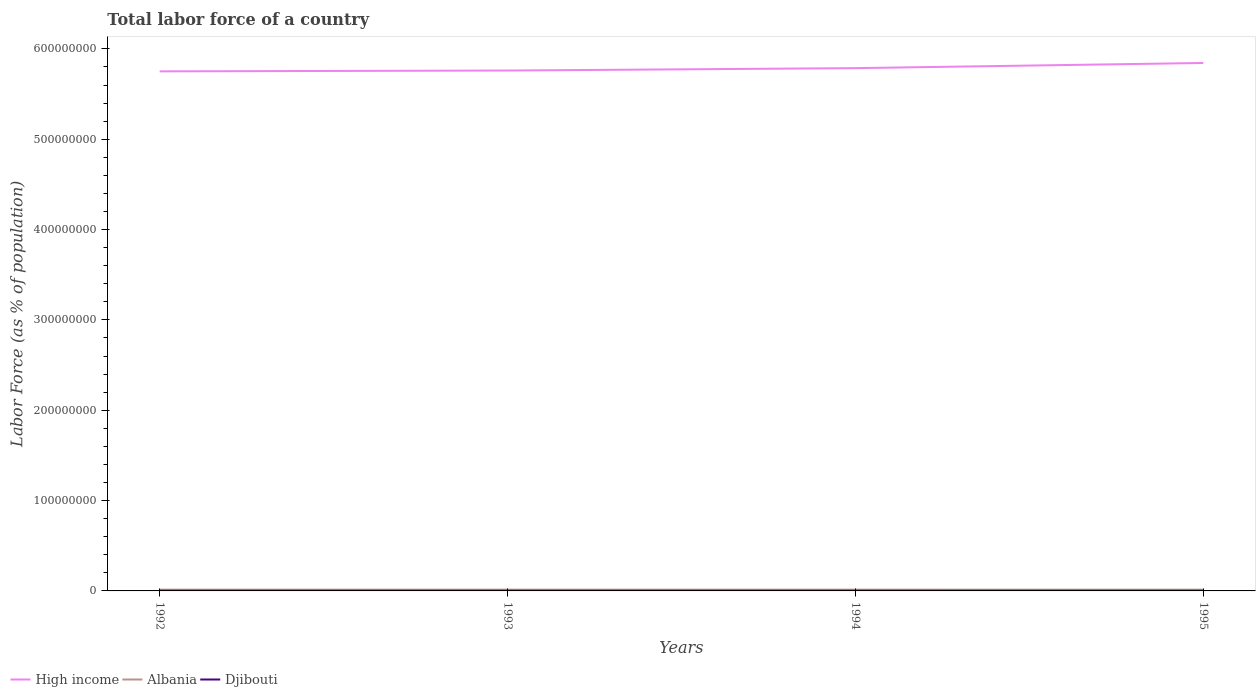How many different coloured lines are there?
Your answer should be very brief. 3. Does the line corresponding to Albania intersect with the line corresponding to High income?
Your answer should be compact. No. Is the number of lines equal to the number of legend labels?
Offer a very short reply. Yes. Across all years, what is the maximum percentage of labor force in Albania?
Give a very brief answer. 1.38e+06. In which year was the percentage of labor force in High income maximum?
Offer a very short reply. 1992. What is the total percentage of labor force in Djibouti in the graph?
Offer a very short reply. -5135. What is the difference between the highest and the second highest percentage of labor force in Djibouti?
Provide a short and direct response. 1.55e+04. How many lines are there?
Make the answer very short. 3. How many years are there in the graph?
Offer a very short reply. 4. What is the difference between two consecutive major ticks on the Y-axis?
Your answer should be compact. 1.00e+08. Are the values on the major ticks of Y-axis written in scientific E-notation?
Offer a terse response. No. How many legend labels are there?
Your answer should be compact. 3. How are the legend labels stacked?
Give a very brief answer. Horizontal. What is the title of the graph?
Keep it short and to the point. Total labor force of a country. Does "Saudi Arabia" appear as one of the legend labels in the graph?
Ensure brevity in your answer.  No. What is the label or title of the Y-axis?
Give a very brief answer. Labor Force (as % of population). What is the Labor Force (as % of population) in High income in 1992?
Give a very brief answer. 5.75e+08. What is the Labor Force (as % of population) of Albania in 1992?
Offer a terse response. 1.42e+06. What is the Labor Force (as % of population) in Djibouti in 1992?
Make the answer very short. 1.63e+05. What is the Labor Force (as % of population) in High income in 1993?
Keep it short and to the point. 5.76e+08. What is the Labor Force (as % of population) in Albania in 1993?
Your answer should be very brief. 1.41e+06. What is the Labor Force (as % of population) of Djibouti in 1993?
Make the answer very short. 1.69e+05. What is the Labor Force (as % of population) of High income in 1994?
Make the answer very short. 5.79e+08. What is the Labor Force (as % of population) of Albania in 1994?
Keep it short and to the point. 1.39e+06. What is the Labor Force (as % of population) of Djibouti in 1994?
Make the answer very short. 1.74e+05. What is the Labor Force (as % of population) of High income in 1995?
Your answer should be compact. 5.84e+08. What is the Labor Force (as % of population) in Albania in 1995?
Offer a very short reply. 1.38e+06. What is the Labor Force (as % of population) of Djibouti in 1995?
Offer a terse response. 1.79e+05. Across all years, what is the maximum Labor Force (as % of population) of High income?
Make the answer very short. 5.84e+08. Across all years, what is the maximum Labor Force (as % of population) in Albania?
Offer a very short reply. 1.42e+06. Across all years, what is the maximum Labor Force (as % of population) of Djibouti?
Provide a short and direct response. 1.79e+05. Across all years, what is the minimum Labor Force (as % of population) in High income?
Provide a succinct answer. 5.75e+08. Across all years, what is the minimum Labor Force (as % of population) of Albania?
Your answer should be very brief. 1.38e+06. Across all years, what is the minimum Labor Force (as % of population) in Djibouti?
Give a very brief answer. 1.63e+05. What is the total Labor Force (as % of population) of High income in the graph?
Provide a short and direct response. 2.31e+09. What is the total Labor Force (as % of population) in Albania in the graph?
Give a very brief answer. 5.59e+06. What is the total Labor Force (as % of population) of Djibouti in the graph?
Make the answer very short. 6.85e+05. What is the difference between the Labor Force (as % of population) of High income in 1992 and that in 1993?
Your response must be concise. -9.15e+05. What is the difference between the Labor Force (as % of population) in Albania in 1992 and that in 1993?
Make the answer very short. 1.21e+04. What is the difference between the Labor Force (as % of population) in Djibouti in 1992 and that in 1993?
Keep it short and to the point. -5453. What is the difference between the Labor Force (as % of population) of High income in 1992 and that in 1994?
Your response must be concise. -3.57e+06. What is the difference between the Labor Force (as % of population) of Albania in 1992 and that in 1994?
Your response must be concise. 2.33e+04. What is the difference between the Labor Force (as % of population) in Djibouti in 1992 and that in 1994?
Your response must be concise. -1.06e+04. What is the difference between the Labor Force (as % of population) of High income in 1992 and that in 1995?
Provide a short and direct response. -9.29e+06. What is the difference between the Labor Force (as % of population) of Albania in 1992 and that in 1995?
Your answer should be compact. 4.10e+04. What is the difference between the Labor Force (as % of population) in Djibouti in 1992 and that in 1995?
Make the answer very short. -1.55e+04. What is the difference between the Labor Force (as % of population) of High income in 1993 and that in 1994?
Provide a succinct answer. -2.65e+06. What is the difference between the Labor Force (as % of population) in Albania in 1993 and that in 1994?
Your answer should be compact. 1.12e+04. What is the difference between the Labor Force (as % of population) of Djibouti in 1993 and that in 1994?
Your response must be concise. -5135. What is the difference between the Labor Force (as % of population) of High income in 1993 and that in 1995?
Provide a short and direct response. -8.38e+06. What is the difference between the Labor Force (as % of population) in Albania in 1993 and that in 1995?
Your answer should be very brief. 2.90e+04. What is the difference between the Labor Force (as % of population) in Djibouti in 1993 and that in 1995?
Your answer should be very brief. -1.01e+04. What is the difference between the Labor Force (as % of population) of High income in 1994 and that in 1995?
Your response must be concise. -5.73e+06. What is the difference between the Labor Force (as % of population) of Albania in 1994 and that in 1995?
Provide a succinct answer. 1.78e+04. What is the difference between the Labor Force (as % of population) of Djibouti in 1994 and that in 1995?
Offer a very short reply. -4952. What is the difference between the Labor Force (as % of population) of High income in 1992 and the Labor Force (as % of population) of Albania in 1993?
Your answer should be very brief. 5.74e+08. What is the difference between the Labor Force (as % of population) in High income in 1992 and the Labor Force (as % of population) in Djibouti in 1993?
Offer a very short reply. 5.75e+08. What is the difference between the Labor Force (as % of population) of Albania in 1992 and the Labor Force (as % of population) of Djibouti in 1993?
Provide a succinct answer. 1.25e+06. What is the difference between the Labor Force (as % of population) in High income in 1992 and the Labor Force (as % of population) in Albania in 1994?
Your response must be concise. 5.74e+08. What is the difference between the Labor Force (as % of population) of High income in 1992 and the Labor Force (as % of population) of Djibouti in 1994?
Your response must be concise. 5.75e+08. What is the difference between the Labor Force (as % of population) of Albania in 1992 and the Labor Force (as % of population) of Djibouti in 1994?
Keep it short and to the point. 1.24e+06. What is the difference between the Labor Force (as % of population) of High income in 1992 and the Labor Force (as % of population) of Albania in 1995?
Offer a very short reply. 5.74e+08. What is the difference between the Labor Force (as % of population) in High income in 1992 and the Labor Force (as % of population) in Djibouti in 1995?
Make the answer very short. 5.75e+08. What is the difference between the Labor Force (as % of population) of Albania in 1992 and the Labor Force (as % of population) of Djibouti in 1995?
Offer a very short reply. 1.24e+06. What is the difference between the Labor Force (as % of population) in High income in 1993 and the Labor Force (as % of population) in Albania in 1994?
Make the answer very short. 5.75e+08. What is the difference between the Labor Force (as % of population) of High income in 1993 and the Labor Force (as % of population) of Djibouti in 1994?
Make the answer very short. 5.76e+08. What is the difference between the Labor Force (as % of population) in Albania in 1993 and the Labor Force (as % of population) in Djibouti in 1994?
Provide a short and direct response. 1.23e+06. What is the difference between the Labor Force (as % of population) of High income in 1993 and the Labor Force (as % of population) of Albania in 1995?
Make the answer very short. 5.75e+08. What is the difference between the Labor Force (as % of population) of High income in 1993 and the Labor Force (as % of population) of Djibouti in 1995?
Provide a short and direct response. 5.76e+08. What is the difference between the Labor Force (as % of population) of Albania in 1993 and the Labor Force (as % of population) of Djibouti in 1995?
Provide a succinct answer. 1.23e+06. What is the difference between the Labor Force (as % of population) in High income in 1994 and the Labor Force (as % of population) in Albania in 1995?
Provide a succinct answer. 5.77e+08. What is the difference between the Labor Force (as % of population) of High income in 1994 and the Labor Force (as % of population) of Djibouti in 1995?
Your response must be concise. 5.78e+08. What is the difference between the Labor Force (as % of population) of Albania in 1994 and the Labor Force (as % of population) of Djibouti in 1995?
Keep it short and to the point. 1.21e+06. What is the average Labor Force (as % of population) in High income per year?
Make the answer very short. 5.79e+08. What is the average Labor Force (as % of population) in Albania per year?
Keep it short and to the point. 1.40e+06. What is the average Labor Force (as % of population) of Djibouti per year?
Ensure brevity in your answer.  1.71e+05. In the year 1992, what is the difference between the Labor Force (as % of population) of High income and Labor Force (as % of population) of Albania?
Provide a succinct answer. 5.74e+08. In the year 1992, what is the difference between the Labor Force (as % of population) of High income and Labor Force (as % of population) of Djibouti?
Offer a very short reply. 5.75e+08. In the year 1992, what is the difference between the Labor Force (as % of population) of Albania and Labor Force (as % of population) of Djibouti?
Offer a terse response. 1.25e+06. In the year 1993, what is the difference between the Labor Force (as % of population) of High income and Labor Force (as % of population) of Albania?
Offer a terse response. 5.75e+08. In the year 1993, what is the difference between the Labor Force (as % of population) in High income and Labor Force (as % of population) in Djibouti?
Your answer should be very brief. 5.76e+08. In the year 1993, what is the difference between the Labor Force (as % of population) of Albania and Labor Force (as % of population) of Djibouti?
Give a very brief answer. 1.24e+06. In the year 1994, what is the difference between the Labor Force (as % of population) in High income and Labor Force (as % of population) in Albania?
Your answer should be compact. 5.77e+08. In the year 1994, what is the difference between the Labor Force (as % of population) of High income and Labor Force (as % of population) of Djibouti?
Give a very brief answer. 5.78e+08. In the year 1994, what is the difference between the Labor Force (as % of population) of Albania and Labor Force (as % of population) of Djibouti?
Give a very brief answer. 1.22e+06. In the year 1995, what is the difference between the Labor Force (as % of population) in High income and Labor Force (as % of population) in Albania?
Provide a succinct answer. 5.83e+08. In the year 1995, what is the difference between the Labor Force (as % of population) in High income and Labor Force (as % of population) in Djibouti?
Your answer should be compact. 5.84e+08. In the year 1995, what is the difference between the Labor Force (as % of population) of Albania and Labor Force (as % of population) of Djibouti?
Your response must be concise. 1.20e+06. What is the ratio of the Labor Force (as % of population) in High income in 1992 to that in 1993?
Your response must be concise. 1. What is the ratio of the Labor Force (as % of population) of Albania in 1992 to that in 1993?
Ensure brevity in your answer.  1.01. What is the ratio of the Labor Force (as % of population) in Djibouti in 1992 to that in 1993?
Offer a terse response. 0.97. What is the ratio of the Labor Force (as % of population) in Albania in 1992 to that in 1994?
Provide a succinct answer. 1.02. What is the ratio of the Labor Force (as % of population) of Djibouti in 1992 to that in 1994?
Offer a very short reply. 0.94. What is the ratio of the Labor Force (as % of population) of High income in 1992 to that in 1995?
Your response must be concise. 0.98. What is the ratio of the Labor Force (as % of population) in Albania in 1992 to that in 1995?
Provide a succinct answer. 1.03. What is the ratio of the Labor Force (as % of population) in Djibouti in 1992 to that in 1995?
Keep it short and to the point. 0.91. What is the ratio of the Labor Force (as % of population) in High income in 1993 to that in 1994?
Give a very brief answer. 1. What is the ratio of the Labor Force (as % of population) in Albania in 1993 to that in 1994?
Ensure brevity in your answer.  1.01. What is the ratio of the Labor Force (as % of population) of Djibouti in 1993 to that in 1994?
Keep it short and to the point. 0.97. What is the ratio of the Labor Force (as % of population) in High income in 1993 to that in 1995?
Offer a terse response. 0.99. What is the ratio of the Labor Force (as % of population) of Albania in 1993 to that in 1995?
Provide a short and direct response. 1.02. What is the ratio of the Labor Force (as % of population) in Djibouti in 1993 to that in 1995?
Ensure brevity in your answer.  0.94. What is the ratio of the Labor Force (as % of population) in High income in 1994 to that in 1995?
Make the answer very short. 0.99. What is the ratio of the Labor Force (as % of population) in Albania in 1994 to that in 1995?
Make the answer very short. 1.01. What is the ratio of the Labor Force (as % of population) of Djibouti in 1994 to that in 1995?
Keep it short and to the point. 0.97. What is the difference between the highest and the second highest Labor Force (as % of population) in High income?
Offer a terse response. 5.73e+06. What is the difference between the highest and the second highest Labor Force (as % of population) of Albania?
Make the answer very short. 1.21e+04. What is the difference between the highest and the second highest Labor Force (as % of population) of Djibouti?
Provide a succinct answer. 4952. What is the difference between the highest and the lowest Labor Force (as % of population) of High income?
Make the answer very short. 9.29e+06. What is the difference between the highest and the lowest Labor Force (as % of population) of Albania?
Make the answer very short. 4.10e+04. What is the difference between the highest and the lowest Labor Force (as % of population) in Djibouti?
Give a very brief answer. 1.55e+04. 